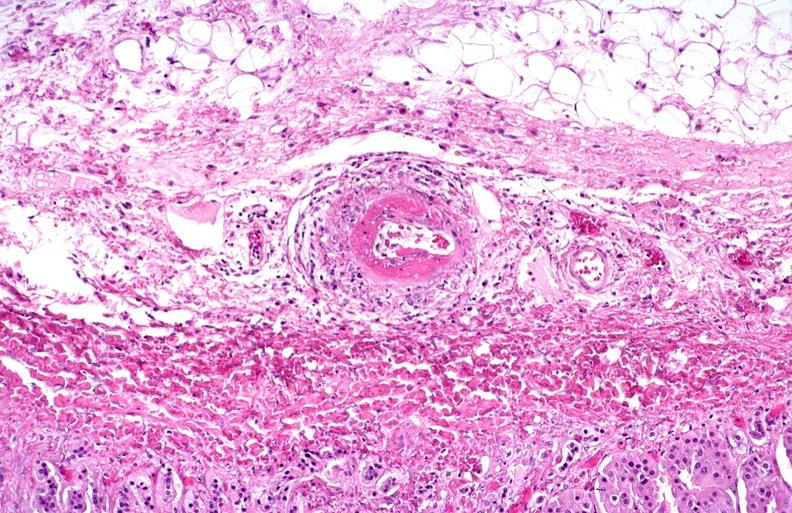what is present?
Answer the question using a single word or phrase. Vasculature 